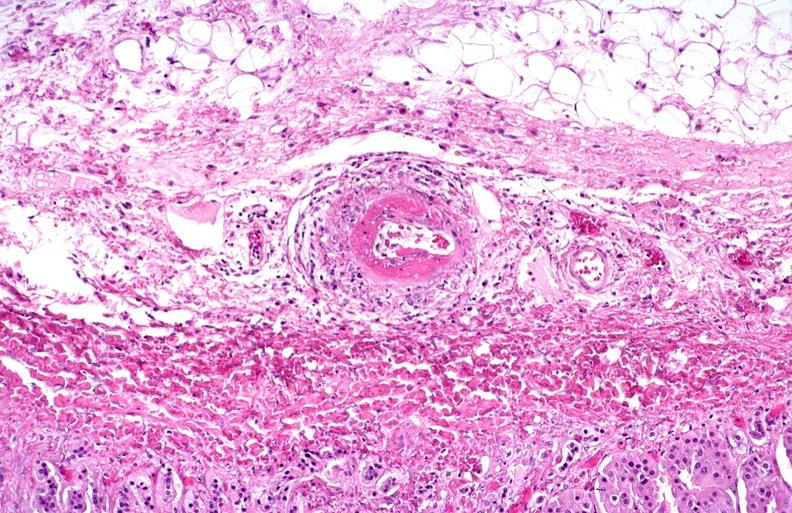what is present?
Answer the question using a single word or phrase. Vasculature 